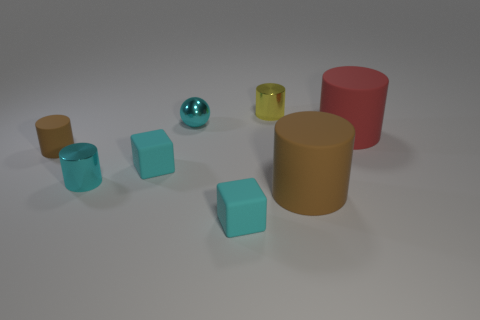How many small objects are either rubber cylinders or red cylinders? In the image, there is a total of one small object that fits the criteria of being either a rubber cylinder or a red cylinder, which is the small red cylinder. 